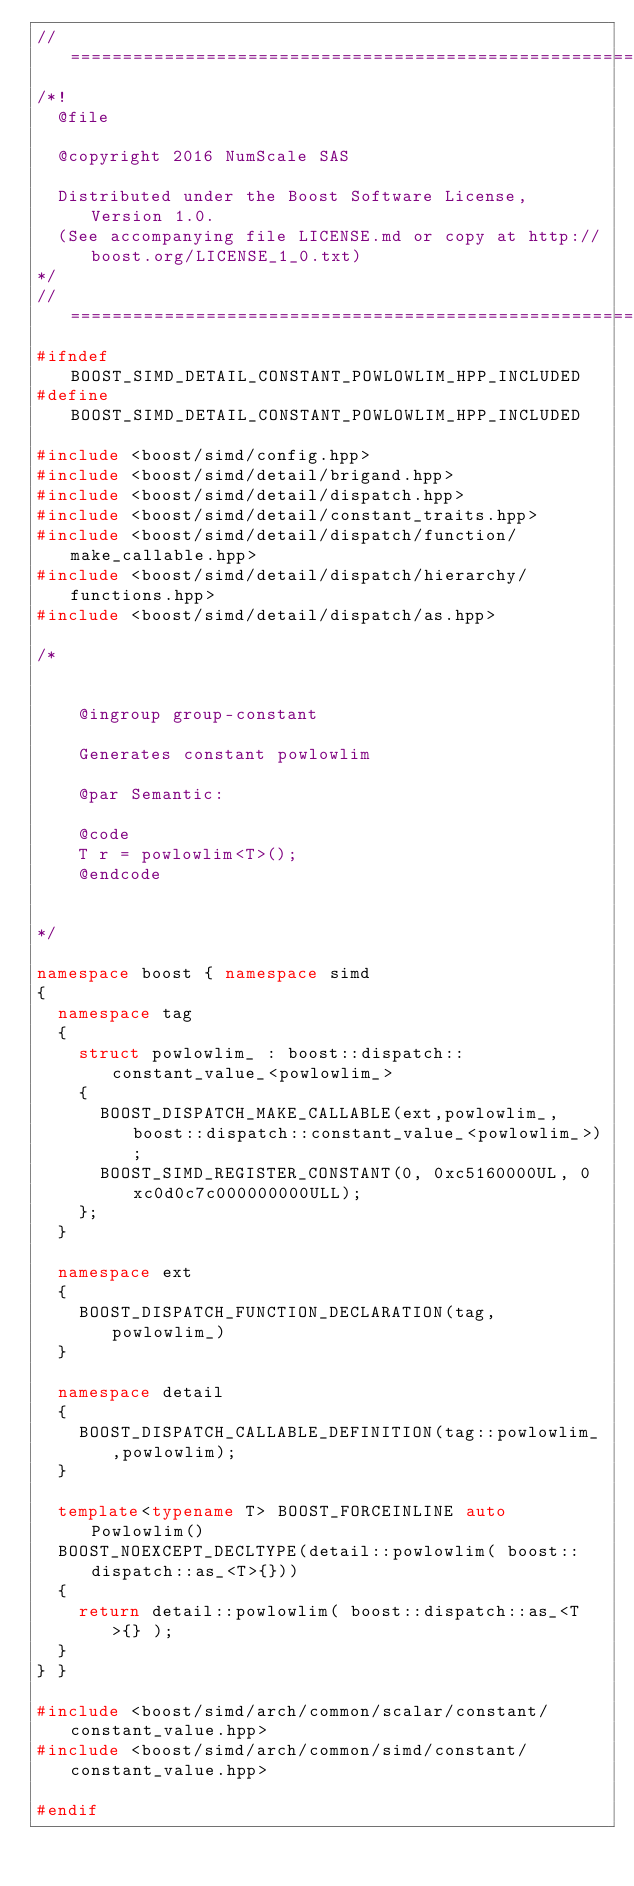<code> <loc_0><loc_0><loc_500><loc_500><_C++_>//==================================================================================================
/*!
  @file

  @copyright 2016 NumScale SAS

  Distributed under the Boost Software License, Version 1.0.
  (See accompanying file LICENSE.md or copy at http://boost.org/LICENSE_1_0.txt)
*/
//==================================================================================================
#ifndef BOOST_SIMD_DETAIL_CONSTANT_POWLOWLIM_HPP_INCLUDED
#define BOOST_SIMD_DETAIL_CONSTANT_POWLOWLIM_HPP_INCLUDED

#include <boost/simd/config.hpp>
#include <boost/simd/detail/brigand.hpp>
#include <boost/simd/detail/dispatch.hpp>
#include <boost/simd/detail/constant_traits.hpp>
#include <boost/simd/detail/dispatch/function/make_callable.hpp>
#include <boost/simd/detail/dispatch/hierarchy/functions.hpp>
#include <boost/simd/detail/dispatch/as.hpp>

/*


    @ingroup group-constant

    Generates constant powlowlim

    @par Semantic:

    @code
    T r = powlowlim<T>();
    @endcode


*/

namespace boost { namespace simd
{
  namespace tag
  {
    struct powlowlim_ : boost::dispatch::constant_value_<powlowlim_>
    {
      BOOST_DISPATCH_MAKE_CALLABLE(ext,powlowlim_,boost::dispatch::constant_value_<powlowlim_>);
      BOOST_SIMD_REGISTER_CONSTANT(0, 0xc5160000UL, 0xc0d0c7c000000000ULL);
    };
  }

  namespace ext
  {
    BOOST_DISPATCH_FUNCTION_DECLARATION(tag, powlowlim_)
  }

  namespace detail
  {
    BOOST_DISPATCH_CALLABLE_DEFINITION(tag::powlowlim_,powlowlim);
  }

  template<typename T> BOOST_FORCEINLINE auto Powlowlim()
  BOOST_NOEXCEPT_DECLTYPE(detail::powlowlim( boost::dispatch::as_<T>{}))
  {
    return detail::powlowlim( boost::dispatch::as_<T>{} );
  }
} }

#include <boost/simd/arch/common/scalar/constant/constant_value.hpp>
#include <boost/simd/arch/common/simd/constant/constant_value.hpp>

#endif
</code> 